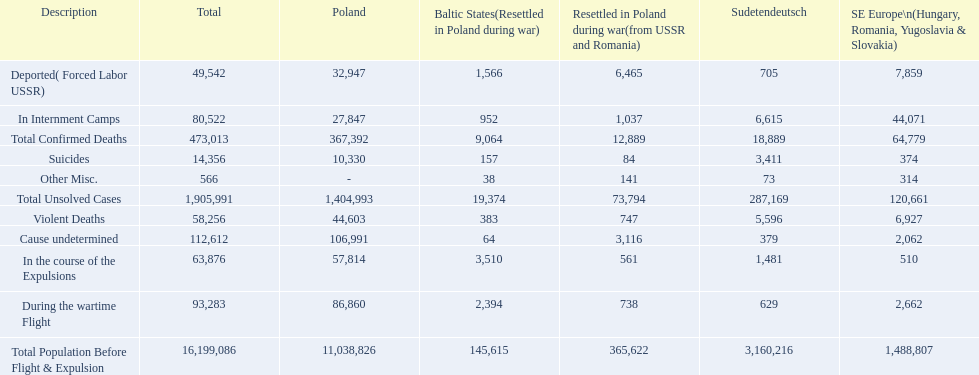How many deaths did the baltic states have in each category? 145,615, 383, 157, 1,566, 952, 2,394, 3,510, 64, 38, 9,064, 19,374. How many cause undetermined deaths did baltic states have? 64. How many other miscellaneous deaths did baltic states have? 38. Which is higher in deaths, cause undetermined or other miscellaneous? Cause undetermined. 